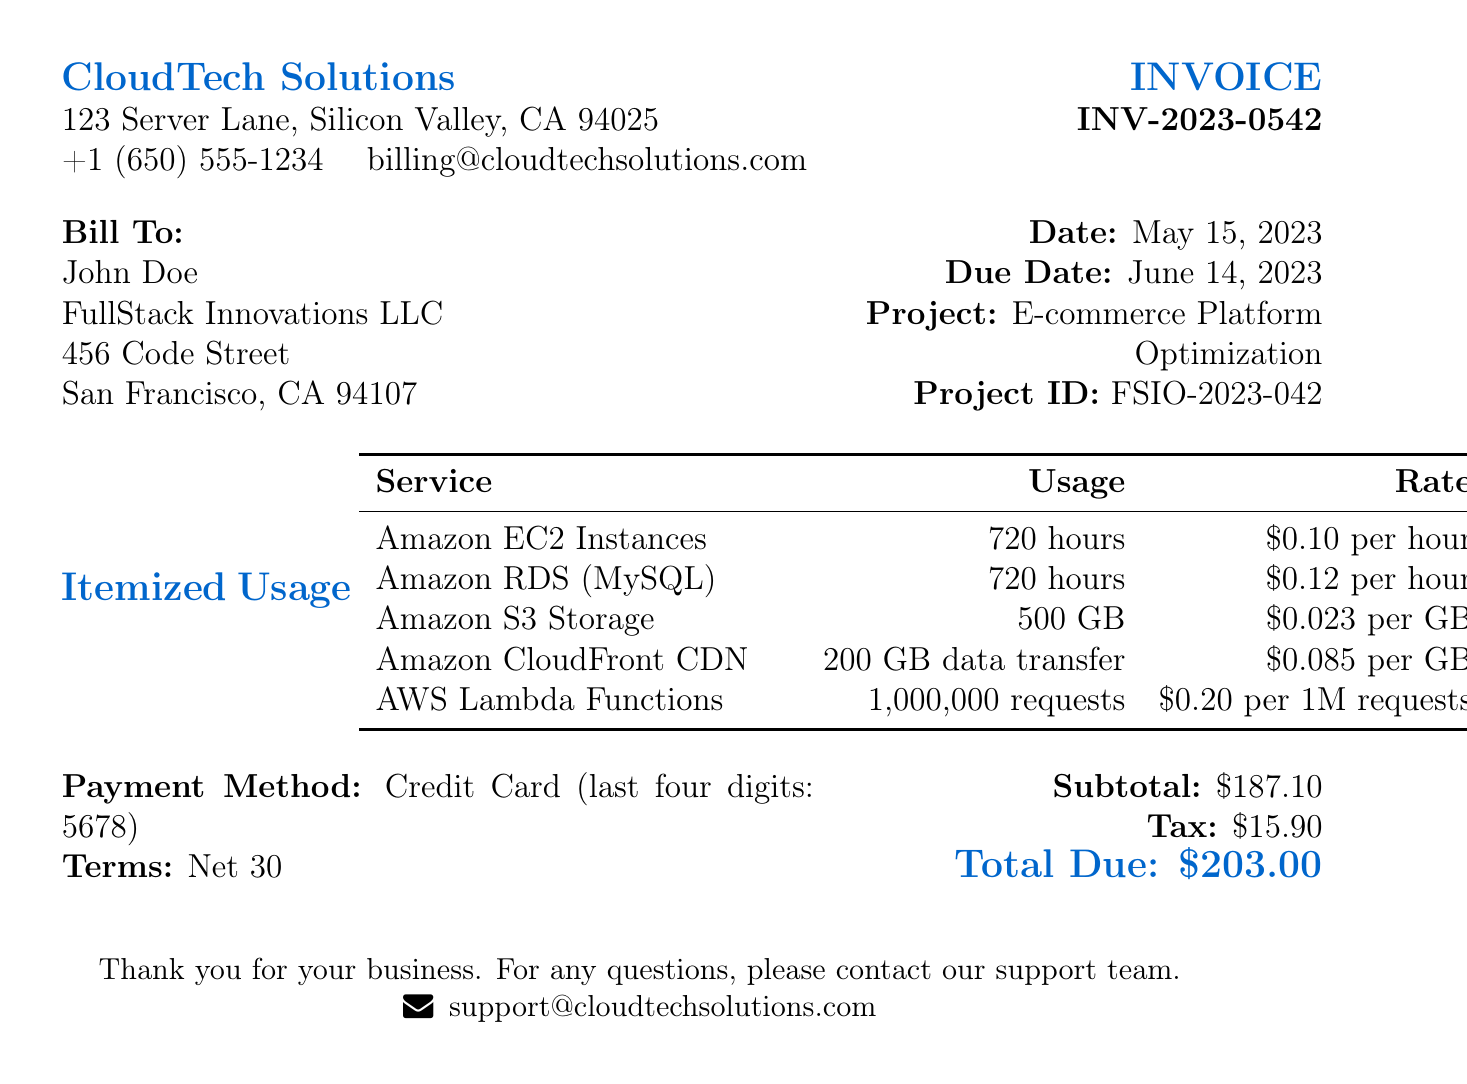What is the invoice number? The invoice number is stated in the document, which is INV-2023-0542.
Answer: INV-2023-0542 Who is the billed entity? The document specifies the billing entity as John Doe from FullStack Innovations LLC.
Answer: John Doe What is the subtotal amount? The subtotal amount is clearly listed in the document as $187.10.
Answer: $187.10 What date is the invoice issued? The date of the invoice can be found in the document, which is May 15, 2023.
Answer: May 15, 2023 What is the total due amount? The total due amount is highlighted in the summary section as $203.00.
Answer: $203.00 How many hours of Amazon EC2 Instances were used? The document lists the usage of Amazon EC2 Instances as 720 hours.
Answer: 720 hours What is the cost of Amazon RDS (MySQL)? The document specifies the cost for Amazon RDS (MySQL) as $86.40.
Answer: $86.40 What is the payment method specified in the invoice? The invoice states the payment method used as Credit Card (last four digits: 5678).
Answer: Credit Card (last four digits: 5678) What is the due date for payment? The due date for the payment is indicated as June 14, 2023.
Answer: June 14, 2023 